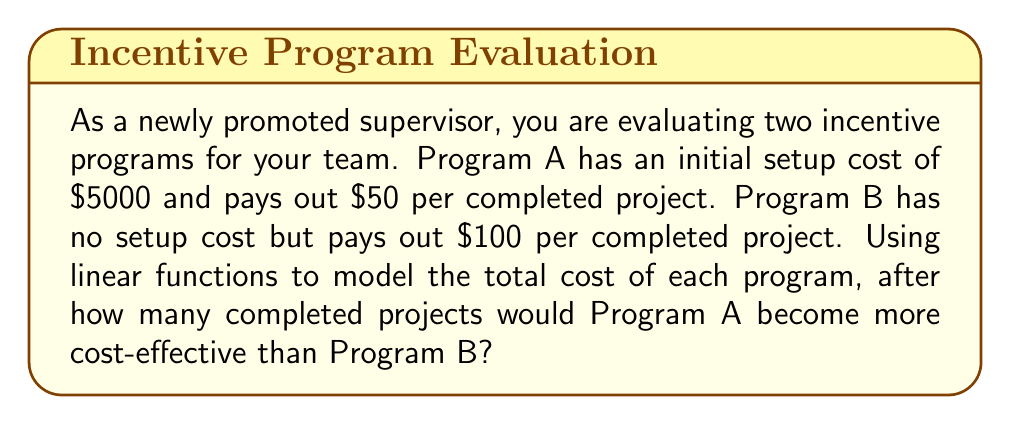Help me with this question. Let's approach this step-by-step:

1) First, let's define our variables:
   Let $x$ be the number of completed projects
   Let $y_A$ be the total cost of Program A
   Let $y_B$ be the total cost of Program B

2) Now, we can write linear functions for each program:
   Program A: $y_A = 5000 + 50x$
   Program B: $y_B = 100x$

3) To find when Program A becomes more cost-effective, we need to find the point where the costs are equal:
   $y_A = y_B$
   $5000 + 50x = 100x$

4) Solve the equation:
   $5000 + 50x = 100x$
   $5000 = 100x - 50x$
   $5000 = 50x$
   $x = 5000 / 50 = 100$

5) Interpret the result:
   At 100 projects, the costs are equal. After this point, Program A becomes more cost-effective.

6) To verify, let's calculate the cost at 101 projects:
   Program A: $y_A = 5000 + 50(101) = 10050$
   Program B: $y_B = 100(101) = 10100$

   We can see that Program A is indeed cheaper after 100 projects.
Answer: 101 projects 